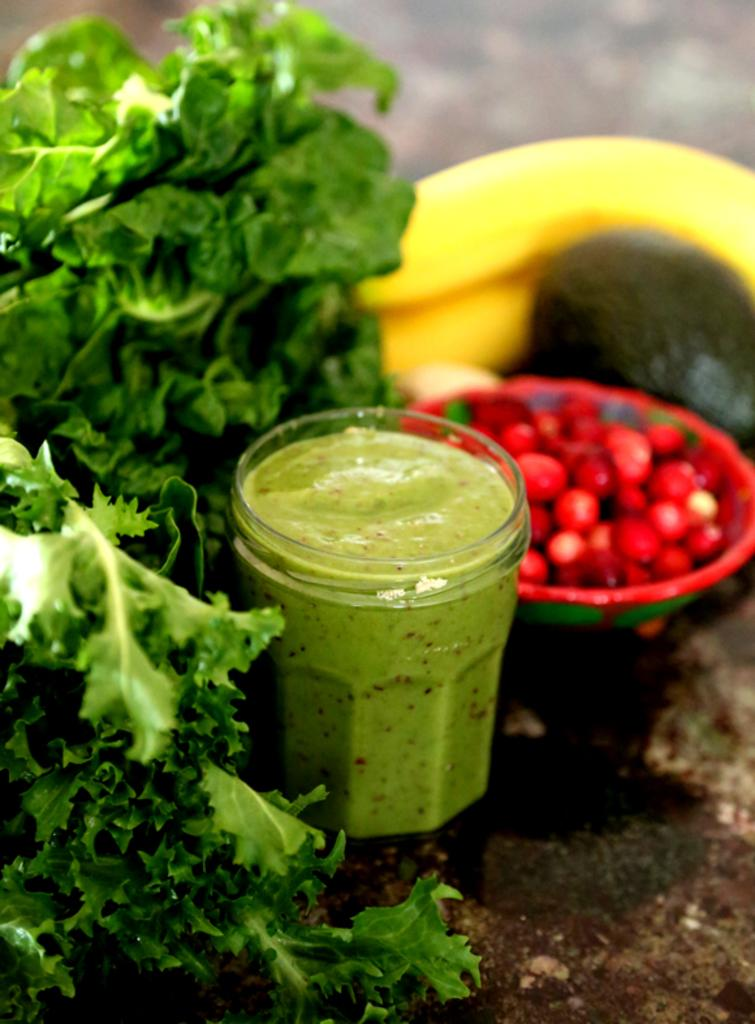What type of food items can be seen in the image? There are leafy vegetables, a banana, and fruits in a bowl in the image. What is the jar of sauce used for? The jar of sauce is likely used for flavoring or enhancing the taste of the food items in the image. Can you describe the fruits in the bowl? The image shows a bowl of fruits, but the specific types of fruits cannot be determined from the provided facts. What is the setting of the image? The image may have been taken in a room, but the exact location cannot be determined from the provided facts. What type of goat can be seen grazing near the leafy vegetables in the image? There is no goat present in the image; it features leafy vegetables, a banana, a jar of sauce, and fruits in a bowl. What type of rake is used to harvest the banana in the image? There is no rake present in the image, and bananas do not require a rake for harvesting. 